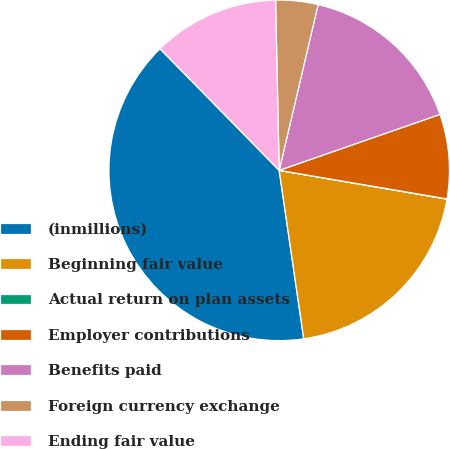<chart> <loc_0><loc_0><loc_500><loc_500><pie_chart><fcel>(inmillions)<fcel>Beginning fair value<fcel>Actual return on plan assets<fcel>Employer contributions<fcel>Benefits paid<fcel>Foreign currency exchange<fcel>Ending fair value<nl><fcel>39.96%<fcel>19.99%<fcel>0.02%<fcel>8.01%<fcel>16.0%<fcel>4.01%<fcel>12.0%<nl></chart> 